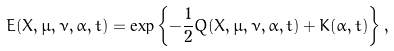<formula> <loc_0><loc_0><loc_500><loc_500>E ( { X } , { \mu } , { \nu } , { \alpha } , t ) = \exp \left \{ - \frac { 1 } { 2 } Q ( { X } , { \mu } , { \nu } , { \alpha } , t ) + K ( { \alpha } , t ) \right \} ,</formula> 